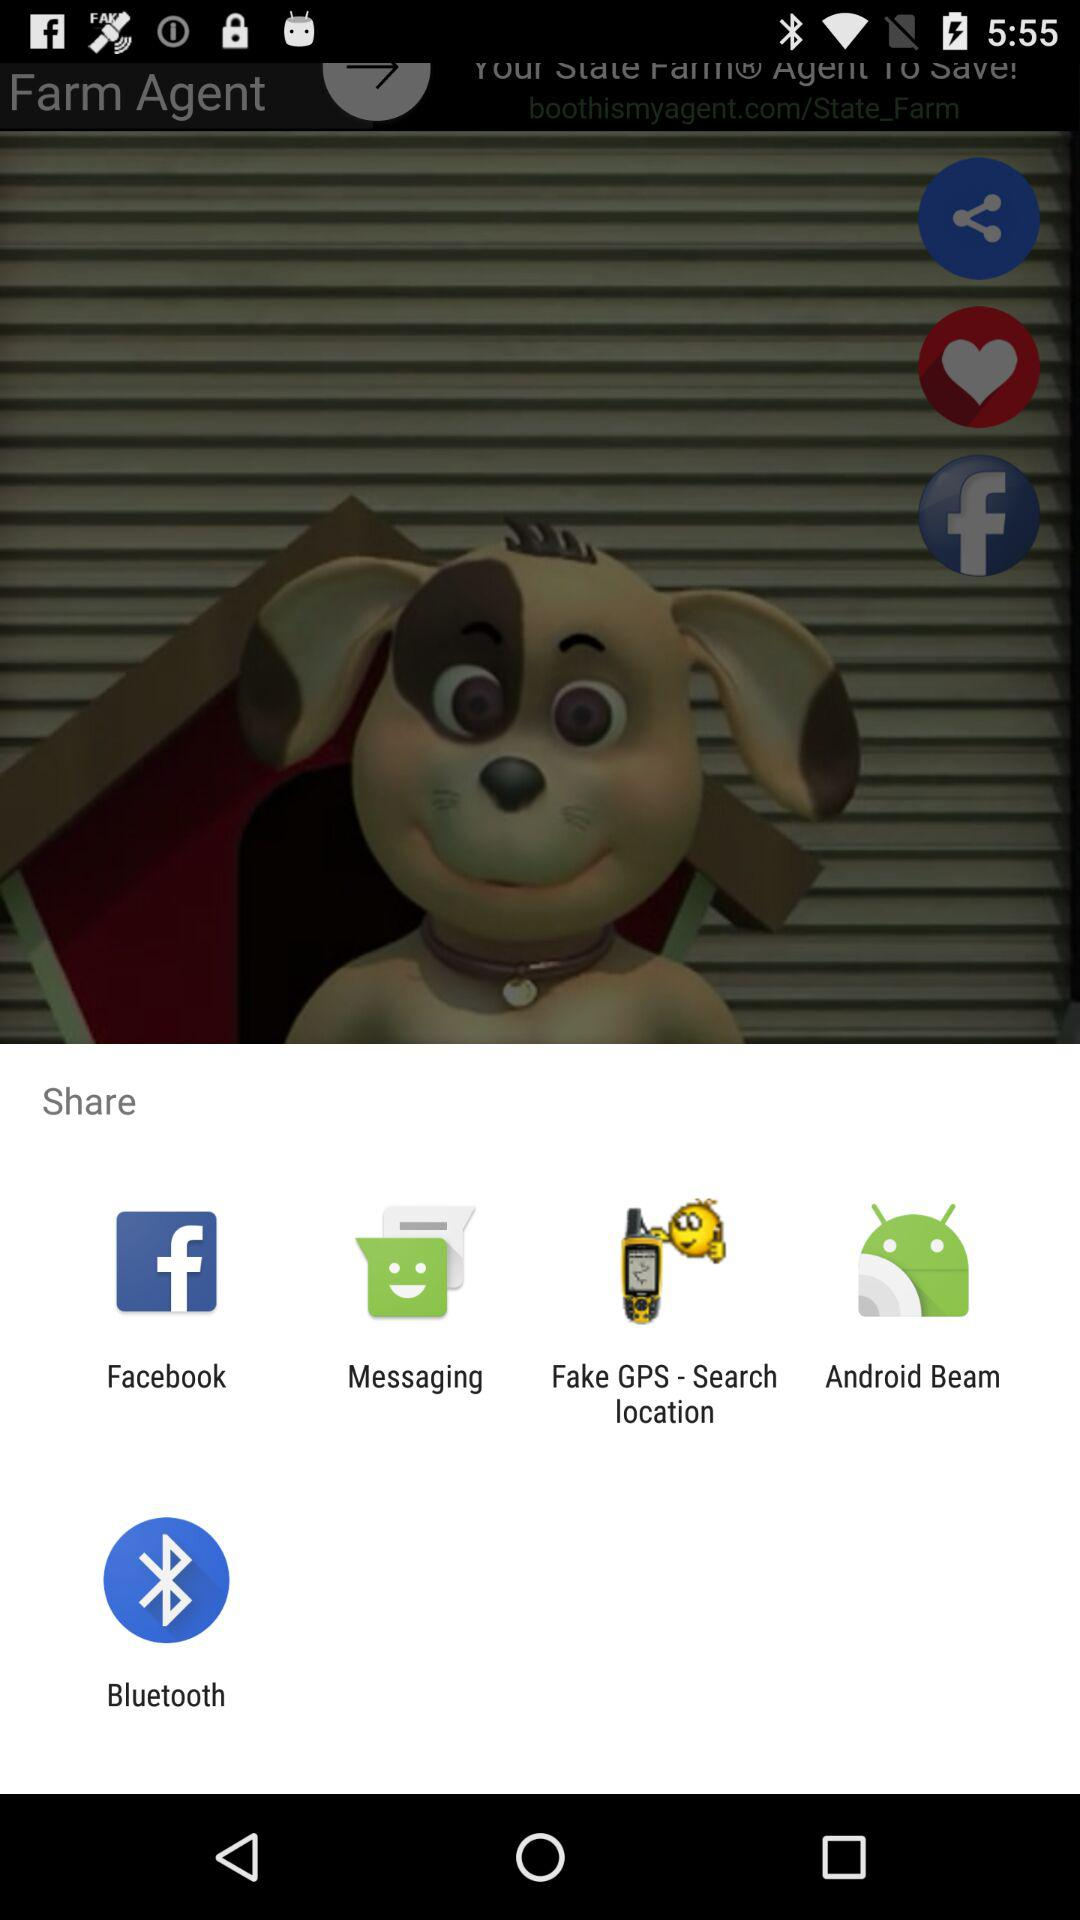Which applications can be used to share the content? The applications that can be used to share the content are "Facebook", "Messaging", "Fake GPS - Search location", "Android Beam" and "Bluetooth". 